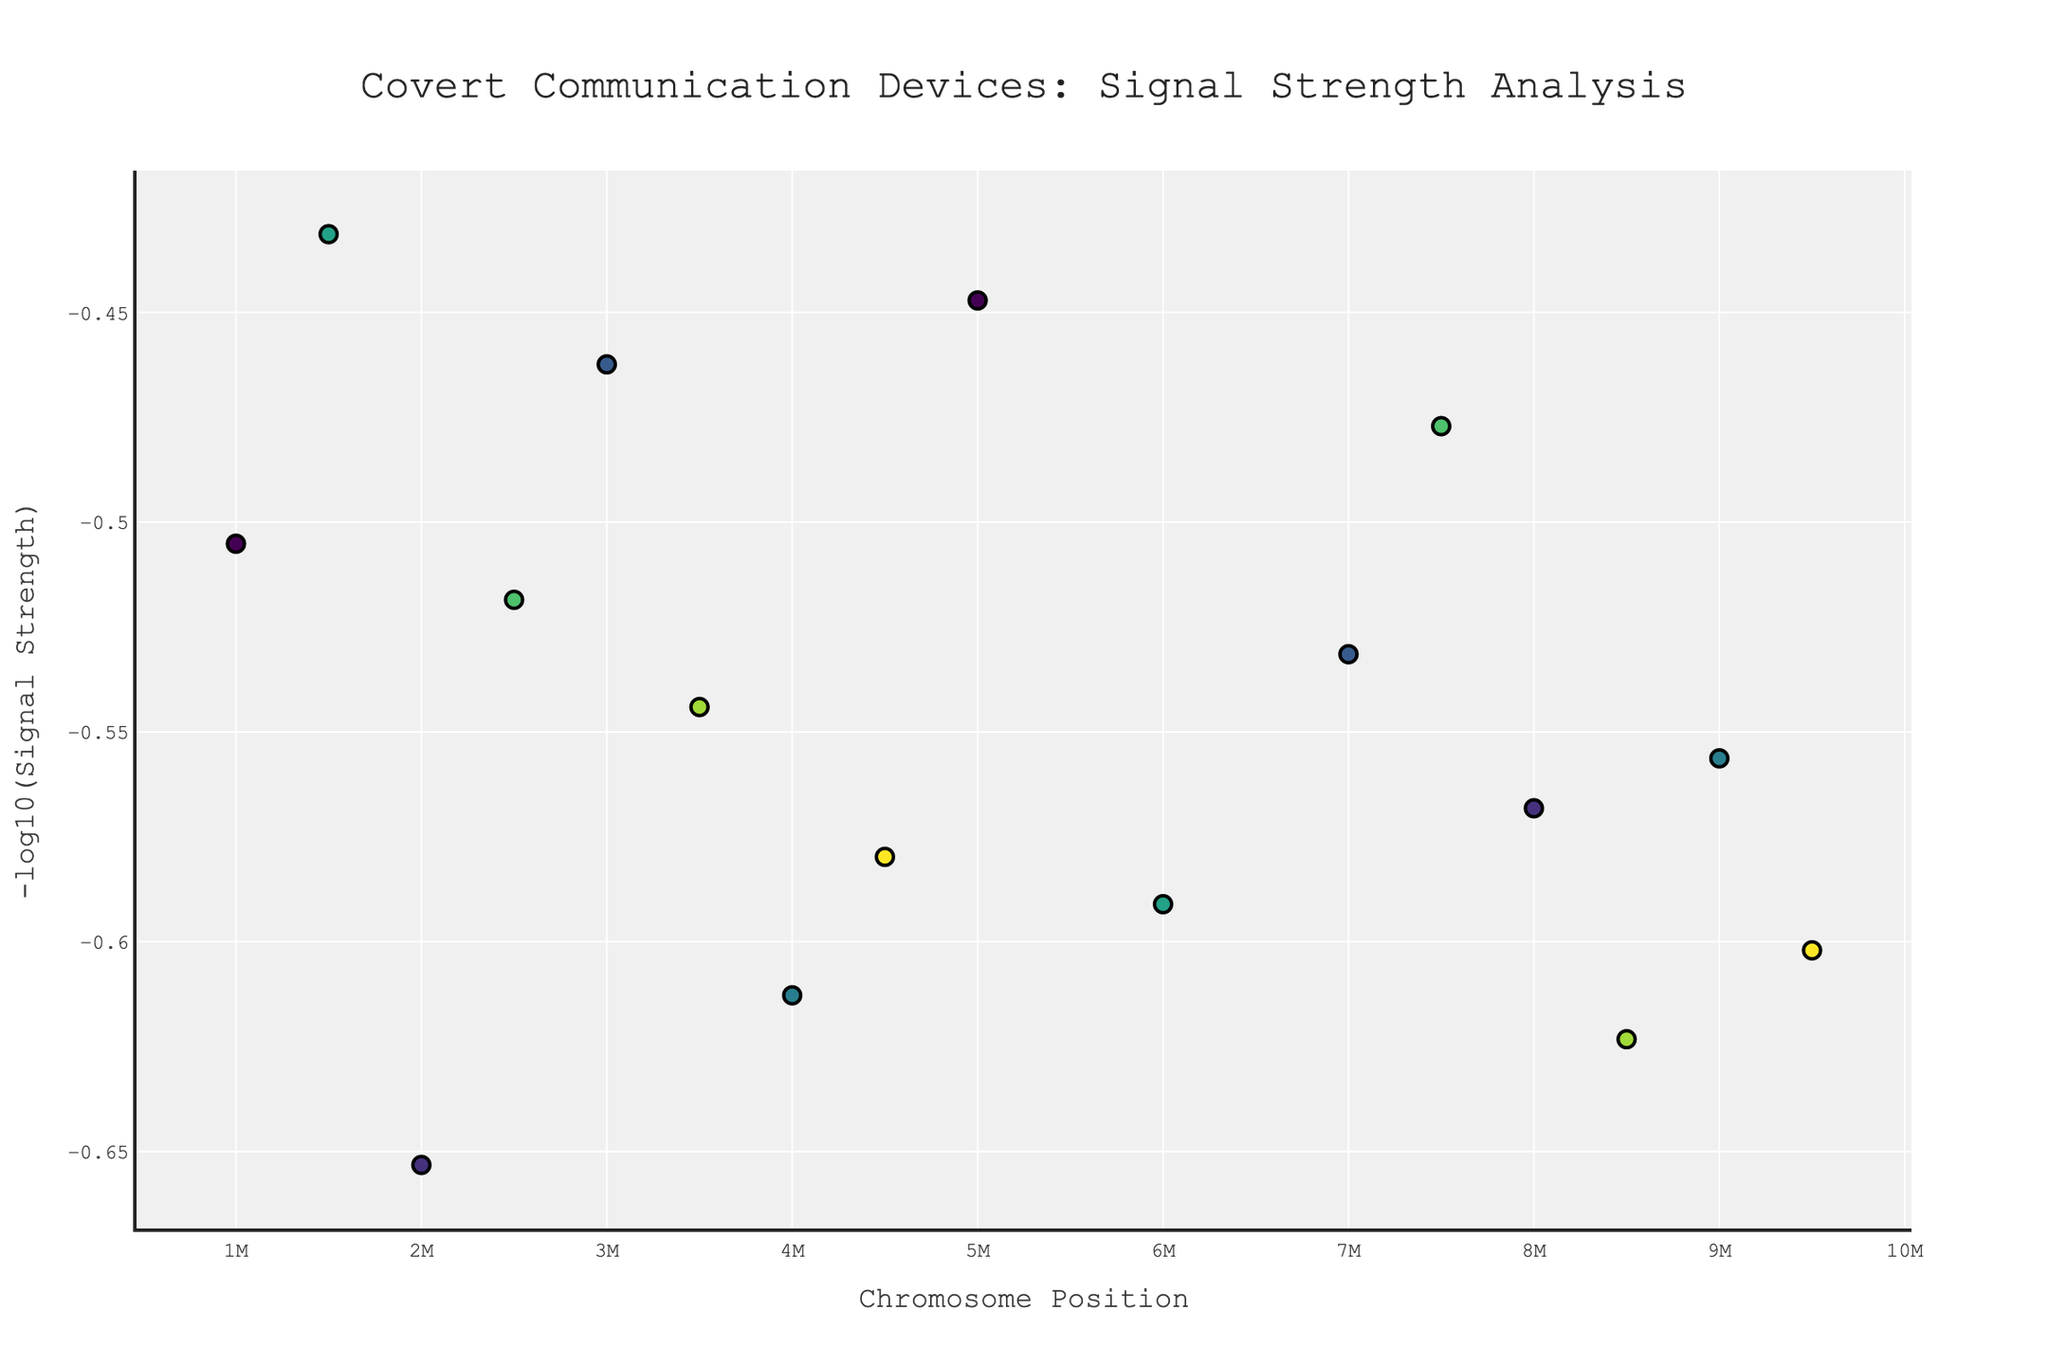How many data points are there in total? By counting the markers on the plot, each representing a data point, we find there are 16 data points.
Answer: 16 What is the title of the plot? The title of a plot is typically found at the top. It reads, "Covert Communication Devices: Signal Strength Analysis".
Answer: Covert Communication Devices: Signal Strength Analysis Which device has the highest signal strength? By identifying the topmost point on the y-axis, we find the Quantum Entanglement Communicator, located at chromosome 2, position 2000000, has the highest signal strength.
Answer: Quantum Entanglement Communicator Which device corresponds to the least signal strength? By identifying the bottommost point on the y-axis, the DNA-Encoded Message Capsule, located at chromosome 5, position 1500000, has the least signal strength.
Answer: DNA-Encoded Message Capsule What is the signal strength of the Quantum Dot Tattoo? Locate the Quantum Dot Tattoo on the plot by its annotation. Then, refer to its y-axis value which represents the -log10(signal strength). This value is 3.0, and its -log10(Signal Strength) is the negative log of the value shown on the plot.
Answer: 3.0 What is the average signal strength of devices on chromosome 4? The devices on chromosome 4 are the Nanobot Swarm Network and Holographic Projection Ring. Their signal strengths are 4.1 and 3.6 respectively. Average = (4.1 + 3.6) / 2 = 3.85.
Answer: 3.85 How does the signal strength of the Brainwave Pattern Encoder compare to the Neural Dust Transmitter? Locate both devices on the plot. The Brainwave Pattern Encoder (-log10(4.0)) has a lower signal strength plotted at approximately 0.6 on the y-axis compared to the Neural Dust Transmitter (-log10(3.7)), plotted lower at approximately 0.43.
Answer: Brainwave Pattern Encoder has a lower signal strength than Neural Dust Transmitter Which chromosome has the widest range of positions for the devices? By comparing the range (difference between the highest and lowest positions) for each chromosome on the x-axis, chromosome 8 spans positions from 4500000 to 9500000, a range of 5000000, which is the widest.
Answer: Chromosome 8 Are there any devices with the exact same signal strength? By looking for markers plotted at the same vertical level (y-value), the Bone Conduction Earpiece and Quantum Dot Tattoo both have the same signal strength (3.0).
Answer: Bone Conduction Earpiece and Quantum Dot Tattoo What is the total number of devices analyzed on chromosome 6? By counting the markers associated with chromosome 6 on the x-axis, we find there are 2 devices: Photonic Crystal Fiber Bowtie and Quantum Dot Tattoo.
Answer: 2 